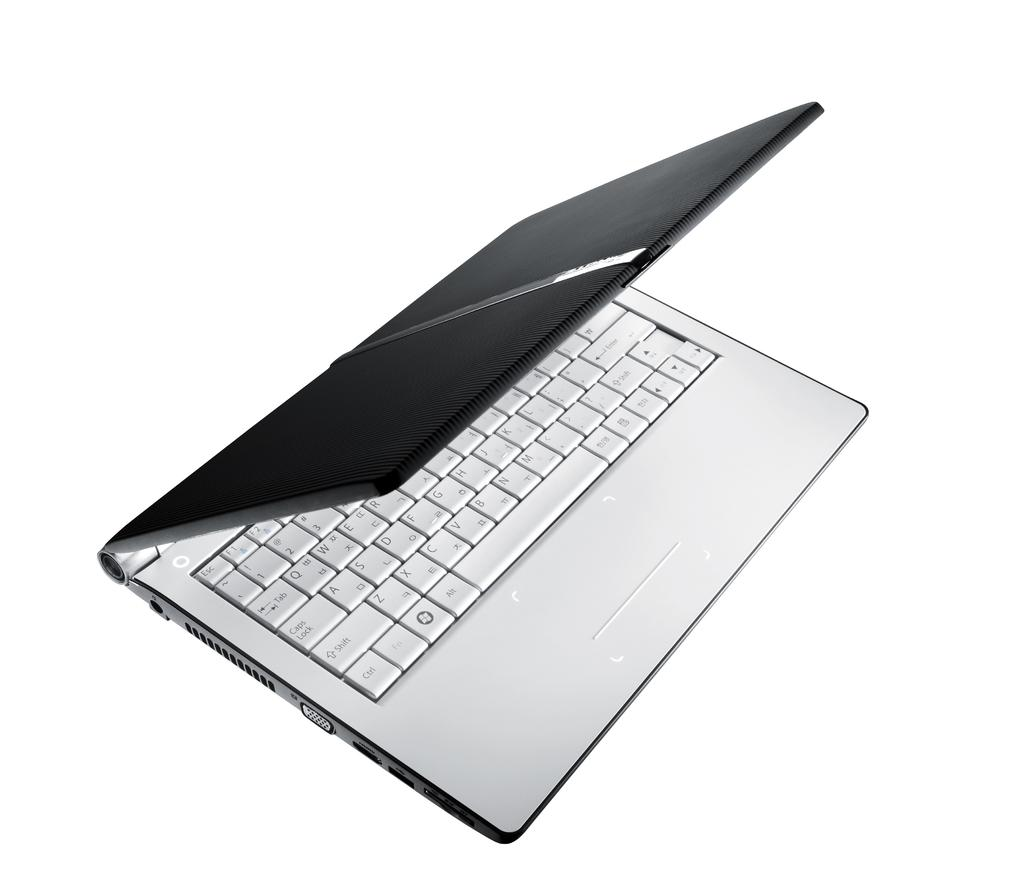Provide a one-sentence caption for the provided image. A laptop has a keyboard with a bunch of keys including shift, ctrl and caps lock. 